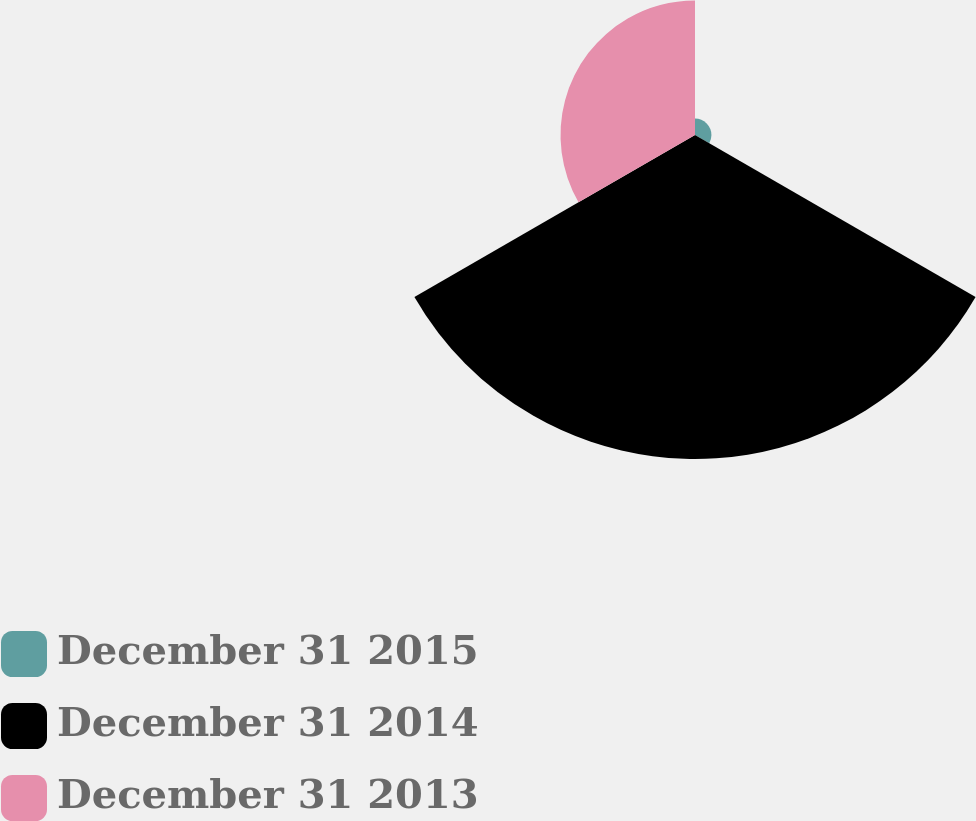<chart> <loc_0><loc_0><loc_500><loc_500><pie_chart><fcel>December 31 2015<fcel>December 31 2014<fcel>December 31 2013<nl><fcel>3.46%<fcel>68.22%<fcel>28.32%<nl></chart> 